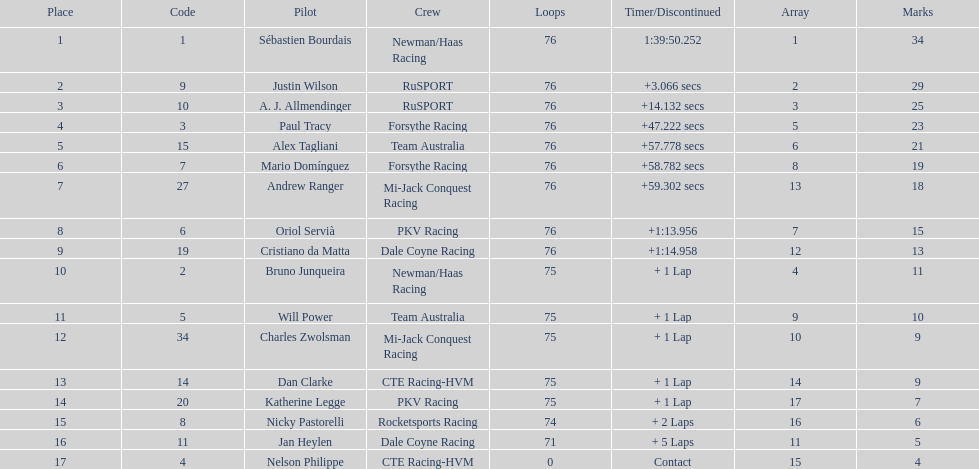Would you be able to parse every entry in this table? {'header': ['Place', 'Code', 'Pilot', 'Crew', 'Loops', 'Timer/Discontinued', 'Array', 'Marks'], 'rows': [['1', '1', 'Sébastien Bourdais', 'Newman/Haas Racing', '76', '1:39:50.252', '1', '34'], ['2', '9', 'Justin Wilson', 'RuSPORT', '76', '+3.066 secs', '2', '29'], ['3', '10', 'A. J. Allmendinger', 'RuSPORT', '76', '+14.132 secs', '3', '25'], ['4', '3', 'Paul Tracy', 'Forsythe Racing', '76', '+47.222 secs', '5', '23'], ['5', '15', 'Alex Tagliani', 'Team Australia', '76', '+57.778 secs', '6', '21'], ['6', '7', 'Mario Domínguez', 'Forsythe Racing', '76', '+58.782 secs', '8', '19'], ['7', '27', 'Andrew Ranger', 'Mi-Jack Conquest Racing', '76', '+59.302 secs', '13', '18'], ['8', '6', 'Oriol Servià', 'PKV Racing', '76', '+1:13.956', '7', '15'], ['9', '19', 'Cristiano da Matta', 'Dale Coyne Racing', '76', '+1:14.958', '12', '13'], ['10', '2', 'Bruno Junqueira', 'Newman/Haas Racing', '75', '+ 1 Lap', '4', '11'], ['11', '5', 'Will Power', 'Team Australia', '75', '+ 1 Lap', '9', '10'], ['12', '34', 'Charles Zwolsman', 'Mi-Jack Conquest Racing', '75', '+ 1 Lap', '10', '9'], ['13', '14', 'Dan Clarke', 'CTE Racing-HVM', '75', '+ 1 Lap', '14', '9'], ['14', '20', 'Katherine Legge', 'PKV Racing', '75', '+ 1 Lap', '17', '7'], ['15', '8', 'Nicky Pastorelli', 'Rocketsports Racing', '74', '+ 2 Laps', '16', '6'], ['16', '11', 'Jan Heylen', 'Dale Coyne Racing', '71', '+ 5 Laps', '11', '5'], ['17', '4', 'Nelson Philippe', 'CTE Racing-HVM', '0', 'Contact', '15', '4']]} How many drivers were competing for brazil? 2. 